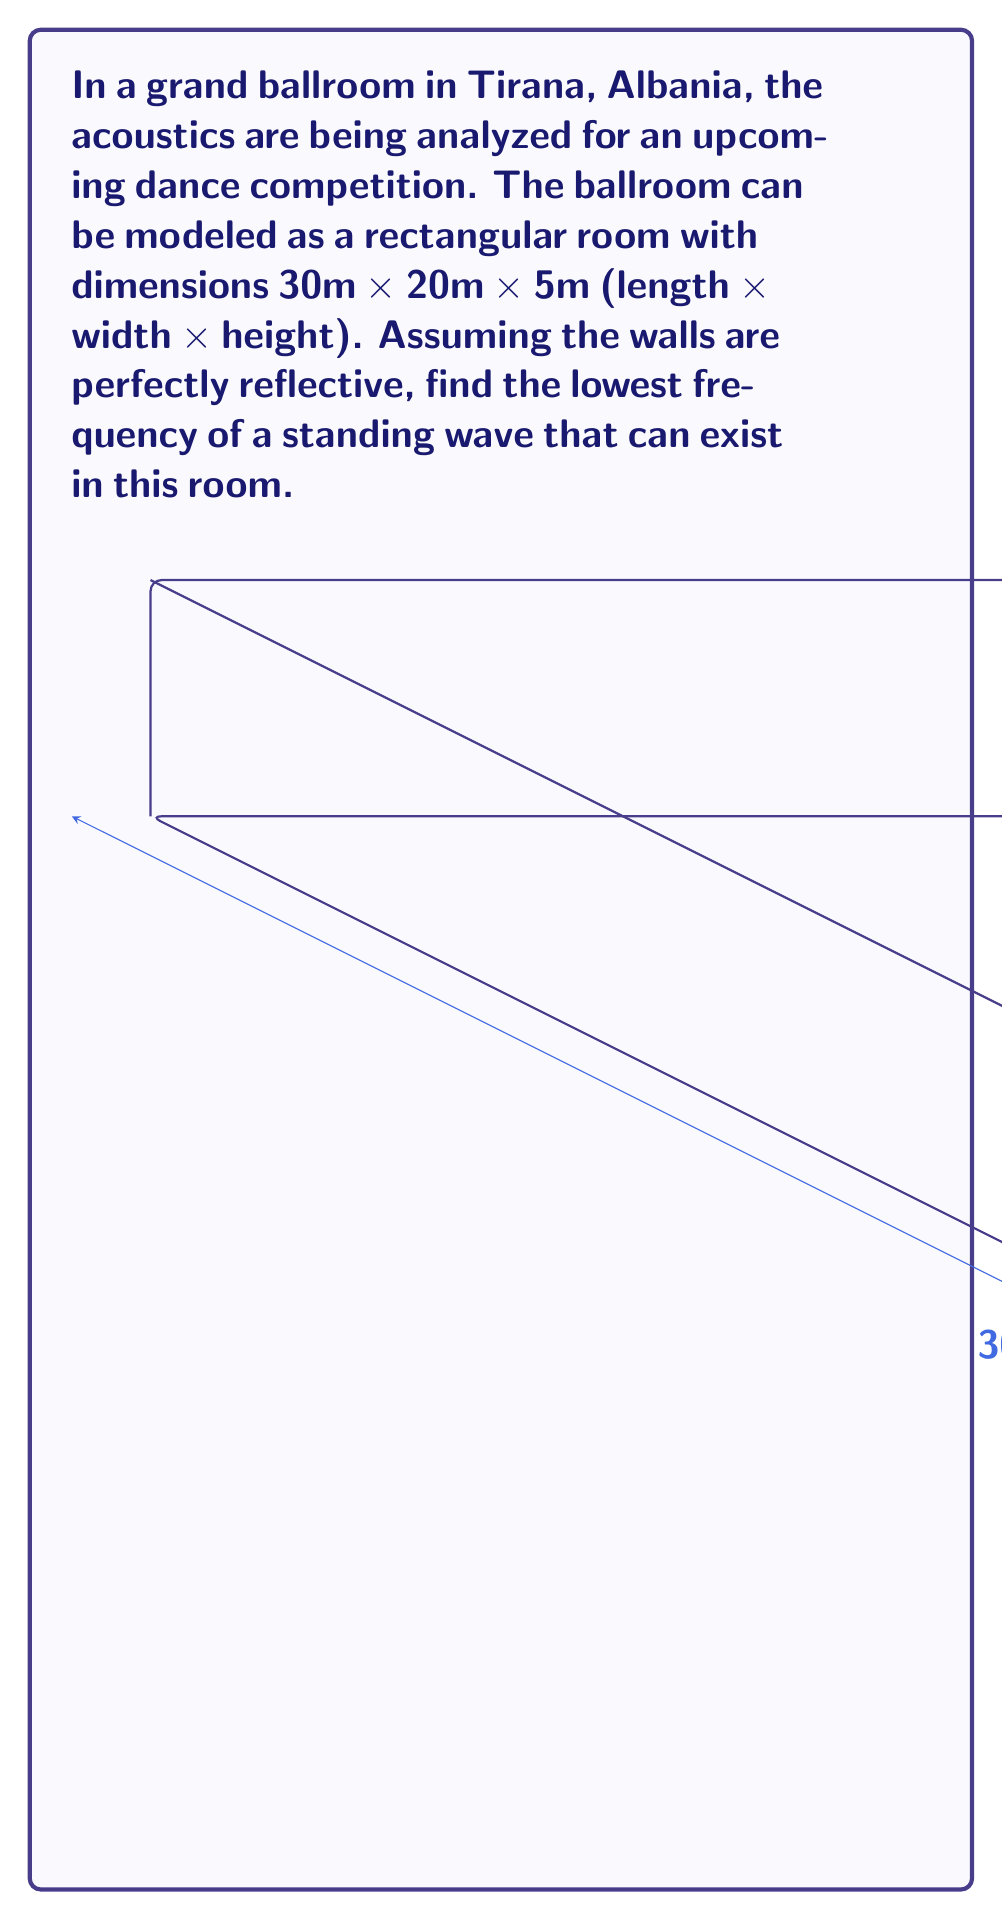Help me with this question. To solve this problem, we need to use the wave equation for a rectangular room with perfectly reflective walls. The frequency of a standing wave in a rectangular room is given by:

$$ f = \frac{c}{2} \sqrt{\left(\frac{n_x}{L_x}\right)^2 + \left(\frac{n_y}{L_y}\right)^2 + \left(\frac{n_z}{L_z}\right)^2} $$

Where:
- $c$ is the speed of sound in air (approximately 343 m/s at room temperature)
- $L_x$, $L_y$, and $L_z$ are the dimensions of the room
- $n_x$, $n_y$, and $n_z$ are non-negative integers representing the mode numbers

The lowest frequency will occur when only one of $n_x$, $n_y$, or $n_z$ is 1, and the others are 0. We need to check which dimension gives the lowest frequency:

For $L_x = 30m$:
$$ f_x = \frac{343}{2(30)} = 5.72 \text{ Hz} $$

For $L_y = 20m$:
$$ f_y = \frac{343}{2(20)} = 8.58 \text{ Hz} $$

For $L_z = 5m$:
$$ f_z = \frac{343}{2(5)} = 34.3 \text{ Hz} $$

The lowest frequency is $f_x = 5.72$ Hz, corresponding to the longest dimension of the room.
Answer: 5.72 Hz 